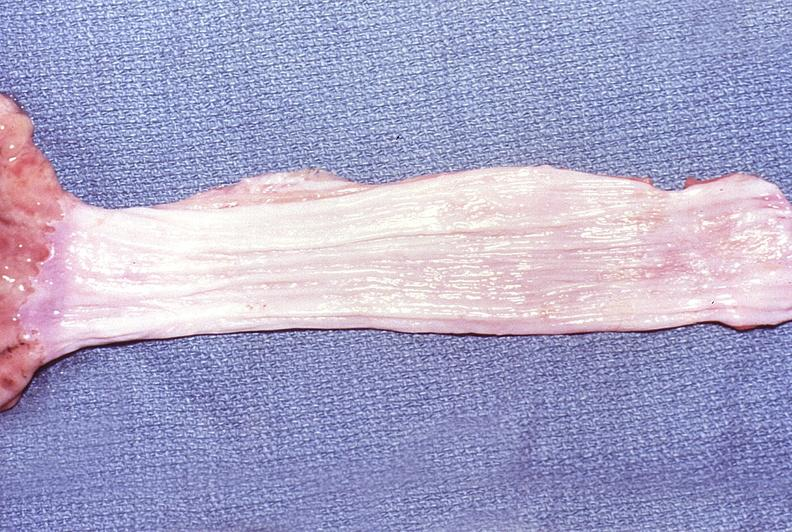what does this image show?
Answer the question using a single word or phrase. Normal esophagus 